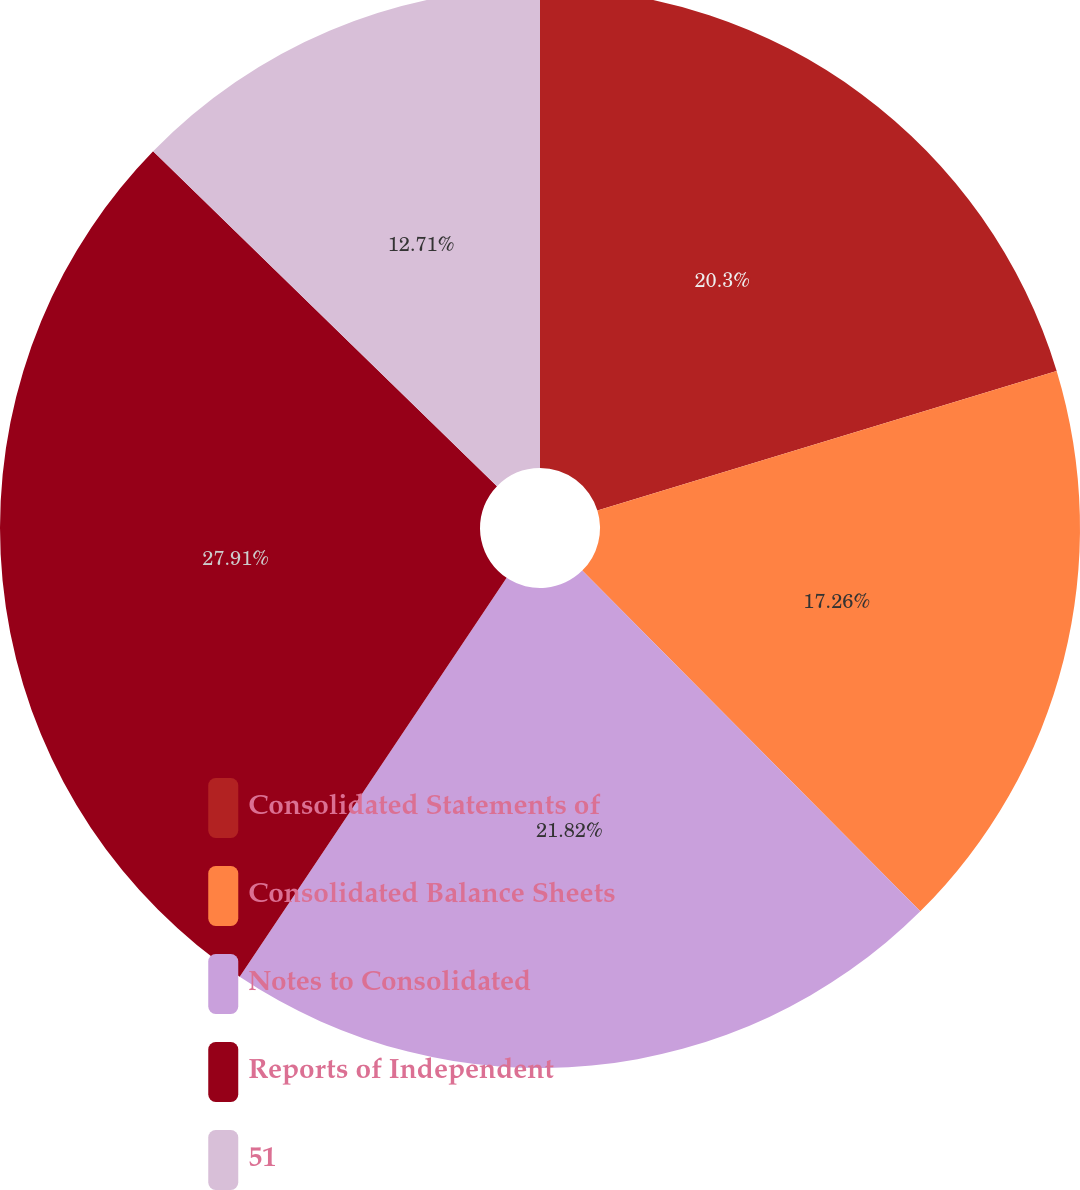<chart> <loc_0><loc_0><loc_500><loc_500><pie_chart><fcel>Consolidated Statements of<fcel>Consolidated Balance Sheets<fcel>Notes to Consolidated<fcel>Reports of Independent<fcel>51<nl><fcel>20.3%<fcel>17.26%<fcel>21.82%<fcel>27.9%<fcel>12.71%<nl></chart> 